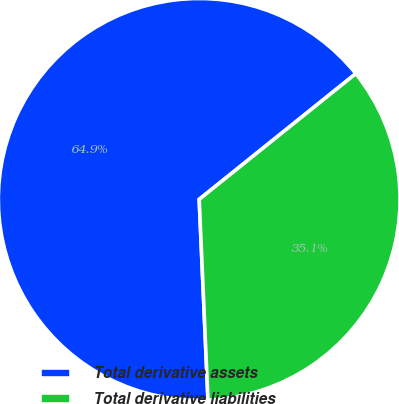<chart> <loc_0><loc_0><loc_500><loc_500><pie_chart><fcel>Total derivative assets<fcel>Total derivative liabilities<nl><fcel>64.93%<fcel>35.07%<nl></chart> 